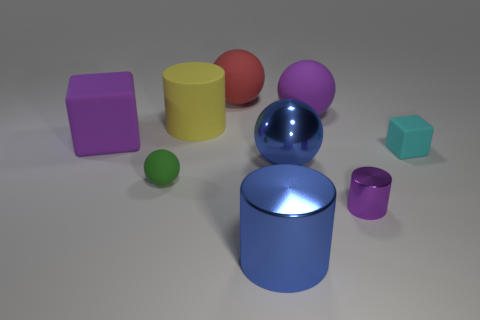Subtract all shiny cylinders. How many cylinders are left? 1 Subtract all purple cylinders. How many cylinders are left? 2 Subtract all cylinders. How many objects are left? 6 Subtract 1 cylinders. How many cylinders are left? 2 Subtract all metal objects. Subtract all yellow objects. How many objects are left? 5 Add 3 big blue metallic spheres. How many big blue metallic spheres are left? 4 Add 9 purple metallic cylinders. How many purple metallic cylinders exist? 10 Subtract 0 gray blocks. How many objects are left? 9 Subtract all blue cubes. Subtract all gray balls. How many cubes are left? 2 Subtract all purple balls. How many brown cubes are left? 0 